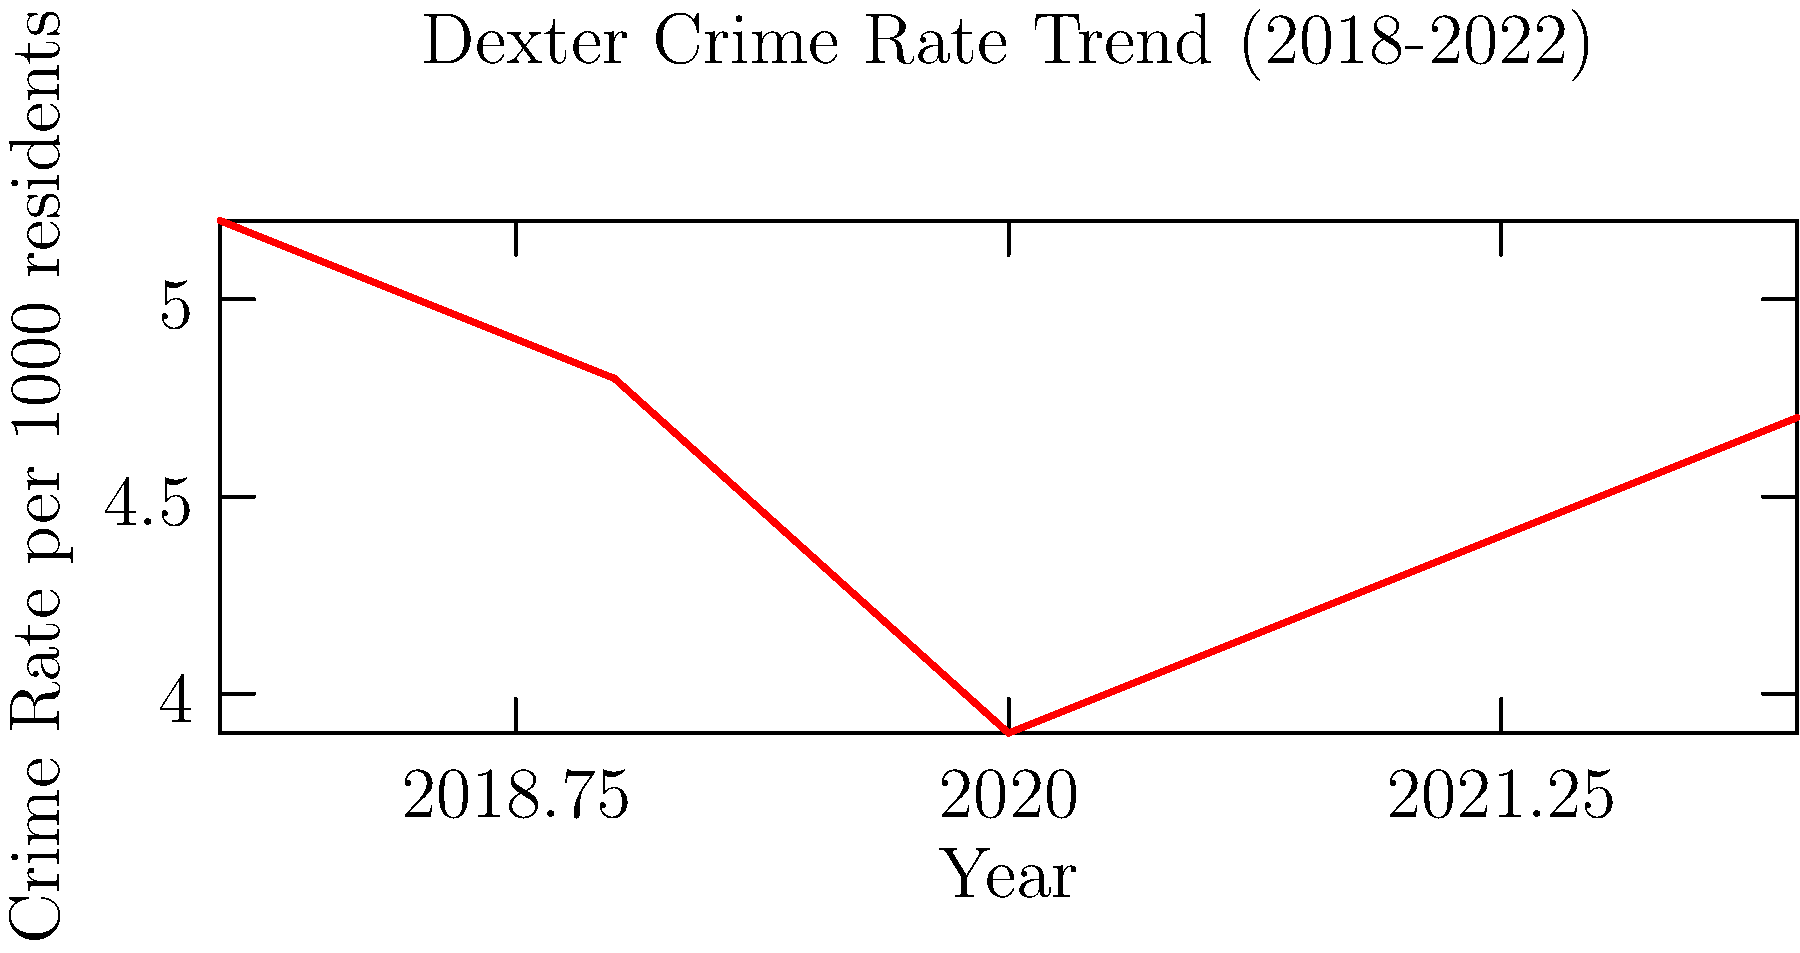As a local journalist in Dexter, you're analyzing the crime rate trends over the past five years. Based on the line graph showing the crime rate per 1000 residents from 2018 to 2022, what was the percentage decrease in crime rate from 2018 to 2020, and what potential factors might explain the subsequent increase in 2021 and 2022? To answer this question, we need to follow these steps:

1. Calculate the percentage decrease in crime rate from 2018 to 2020:
   - 2018 crime rate: 5.2 per 1000 residents
   - 2020 crime rate: 3.9 per 1000 residents
   - Decrease: 5.2 - 3.9 = 1.3
   - Percentage decrease: $\frac{1.3}{5.2} \times 100 = 25\%$

2. Analyze the trend after 2020:
   - The crime rate increased from 3.9 in 2020 to 4.3 in 2021, and further to 4.7 in 2022.

3. Consider potential factors for the increase in 2021 and 2022:
   a. COVID-19 pandemic aftermath: As restrictions eased, there might have been an increase in opportunities for crime.
   b. Economic factors: Potential job losses or financial stress due to the pandemic could lead to increased crime rates.
   c. Social unrest: Any local or national events causing social tension could contribute to higher crime rates.
   d. Changes in policing strategies or resources: Alterations in law enforcement approaches or budget allocations might affect crime rates.
   e. Reporting practices: Changes in how crimes are reported or recorded could influence the statistics.
   f. Population changes: Shifts in local demographics or population size could impact crime rates.

As a community journalist, it would be important to investigate these factors through interviews with local law enforcement, city officials, and community members to provide a comprehensive analysis of the trend.
Answer: 25% decrease from 2018 to 2020; potential factors for subsequent increase: pandemic aftermath, economic stress, social unrest, policing changes, reporting practices, and population shifts. 